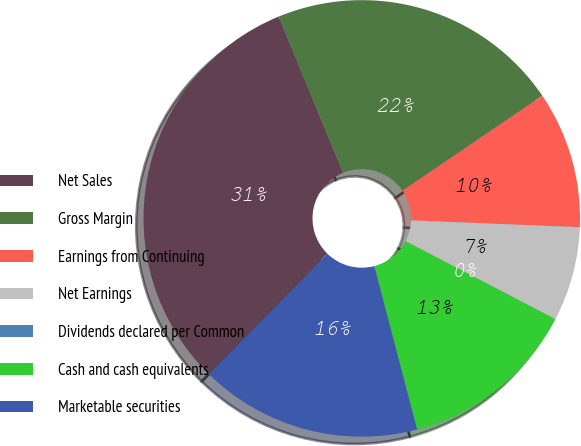<chart> <loc_0><loc_0><loc_500><loc_500><pie_chart><fcel>Net Sales<fcel>Gross Margin<fcel>Earnings from Continuing<fcel>Net Earnings<fcel>Dividends declared per Common<fcel>Cash and cash equivalents<fcel>Marketable securities<nl><fcel>31.43%<fcel>21.72%<fcel>10.14%<fcel>7.0%<fcel>0.0%<fcel>13.28%<fcel>16.43%<nl></chart> 